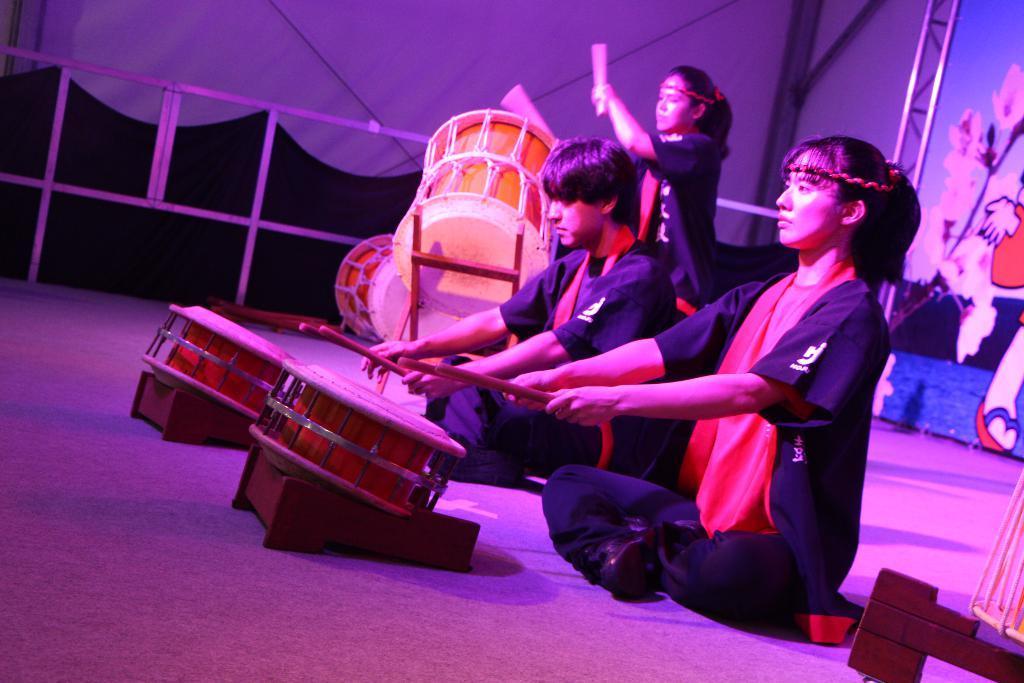How would you summarize this image in a sentence or two? In this image I can see three people sitting on the floor and playing some musical instruments. It seems to be a stage. In the background there is a railing and I can see a white color curtain. On the right side there is a board on which I can see some paintings. 